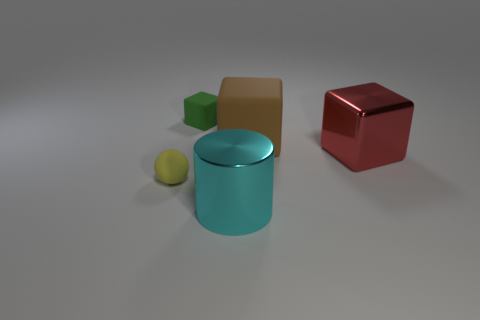Subtract 1 blocks. How many blocks are left? 2 Add 4 small green objects. How many objects exist? 9 Subtract all cubes. How many objects are left? 2 Subtract all small gray rubber things. Subtract all big brown rubber blocks. How many objects are left? 4 Add 2 large red metal objects. How many large red metal objects are left? 3 Add 3 small yellow rubber spheres. How many small yellow rubber spheres exist? 4 Subtract 0 green cylinders. How many objects are left? 5 